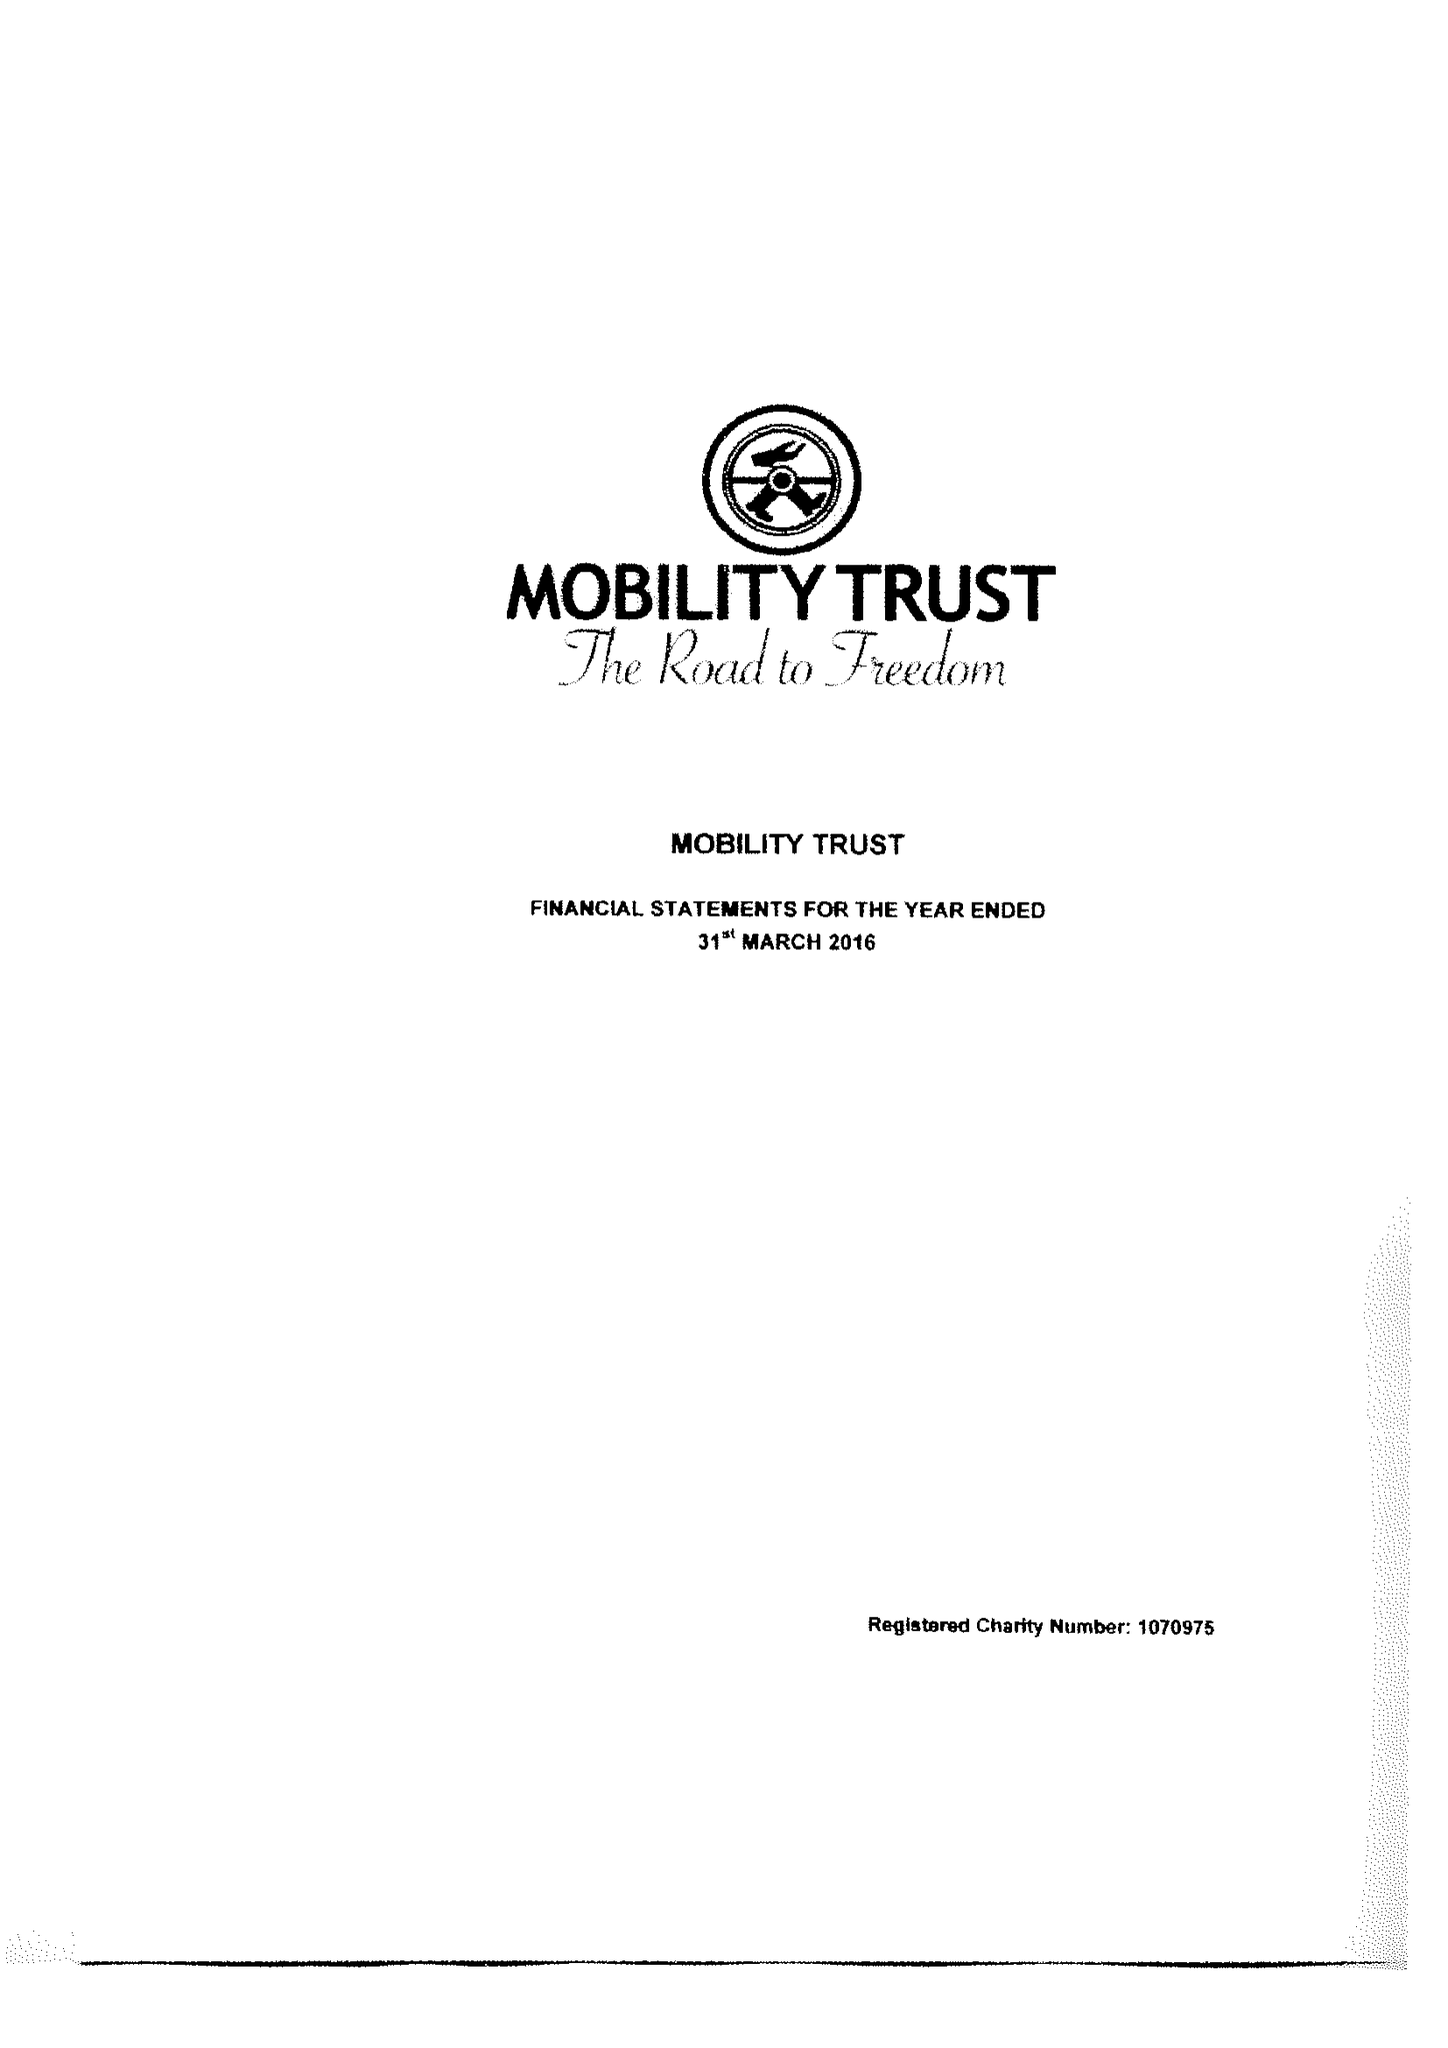What is the value for the spending_annually_in_british_pounds?
Answer the question using a single word or phrase. 312596.00 